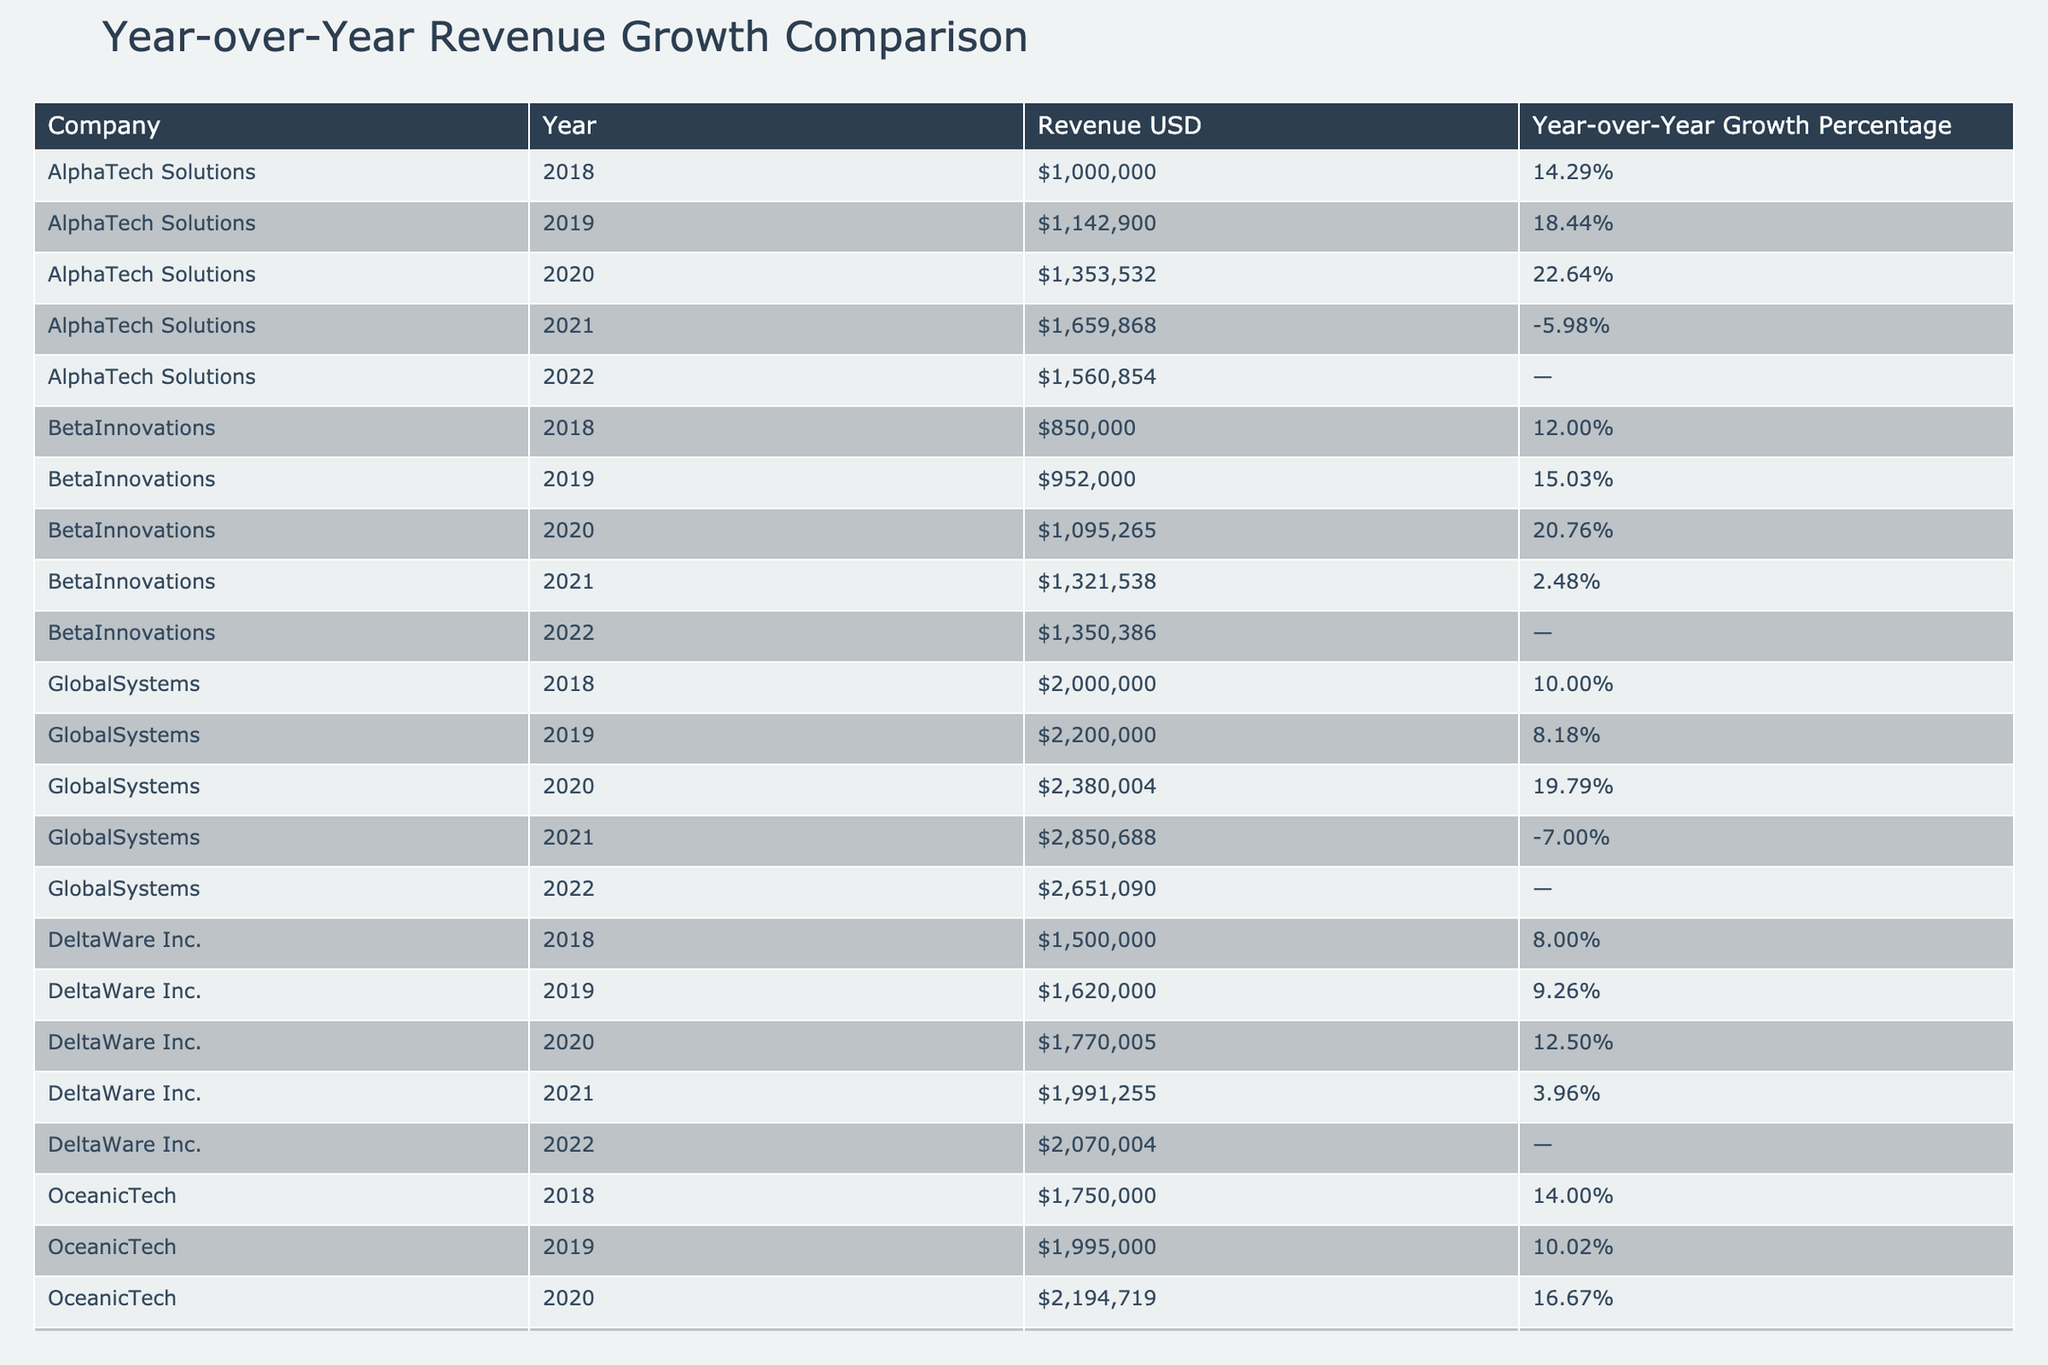What was AlphaTech Solutions' revenue in 2020? The revenue for AlphaTech Solutions in 2020 is listed directly in the table as $1,353,532.
Answer: $1,353,532 Which company had the highest revenue in 2021? By checking the 2021 revenue figures for each company, GlobalSystems had the highest revenue at $2,850,688, compared to others such as AlphaTech Solutions at $1,659,868, BetaInnovations at $1,321,538, DeltaWare Inc. at $1,991,255, and OceanicTech at $2,560,040.
Answer: GlobalSystems What is the average Year-over-Year Growth Percentage for DeltaWare Inc. from 2018 to 2021? The Year-over-Year Growth Percentages for DeltaWare Inc. are 8.00, 9.26, 12.50, and 3.96. To find the average, sum these values: 8.00 + 9.26 + 12.50 + 3.96 = 33.72. Then, divide by 4 (the number of years) to get 33.72 / 4 = 8.43.
Answer: 8.43% Did OceanicTech experience a Year-over-Year growth decline at any point during 2018 to 2021? By examining the Year-over-Year Growth Percentages, we see that OceanicTech had growth percentages of 14.00, 10.02, 16.67, and 4.68. Since none of these values are negative, it can be concluded that OceanicTech did not experience a decline.
Answer: No Which company had the most volatile revenue growth based on Year-over-Year Growth Percentages? By assessing the Year-over-Year Growth Percentages for all companies, AlphaTech Solutions and GlobalSystems show significant fluctuations, including one negative value each. AlphaTech's growth ranged from 22.64 to -5.98, and GlobalSystems ranged from 19.79 to -7.00. AlphaTech shows a higher peak but also a larger drop. Therefore, AlphaTech's revenue growth appears to be more volatile.
Answer: AlphaTech Solutions 